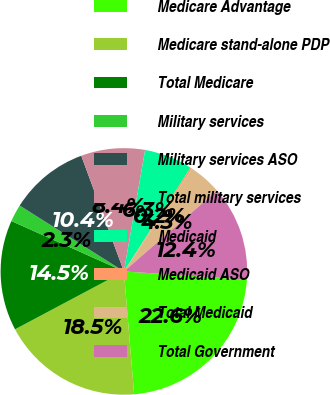<chart> <loc_0><loc_0><loc_500><loc_500><pie_chart><fcel>Medicare Advantage<fcel>Medicare stand-alone PDP<fcel>Total Medicare<fcel>Military services<fcel>Military services ASO<fcel>Total military services<fcel>Medicaid<fcel>Medicaid ASO<fcel>Total Medicaid<fcel>Total Government<nl><fcel>22.62%<fcel>18.55%<fcel>14.48%<fcel>2.27%<fcel>10.41%<fcel>8.37%<fcel>6.34%<fcel>0.23%<fcel>4.3%<fcel>12.44%<nl></chart> 